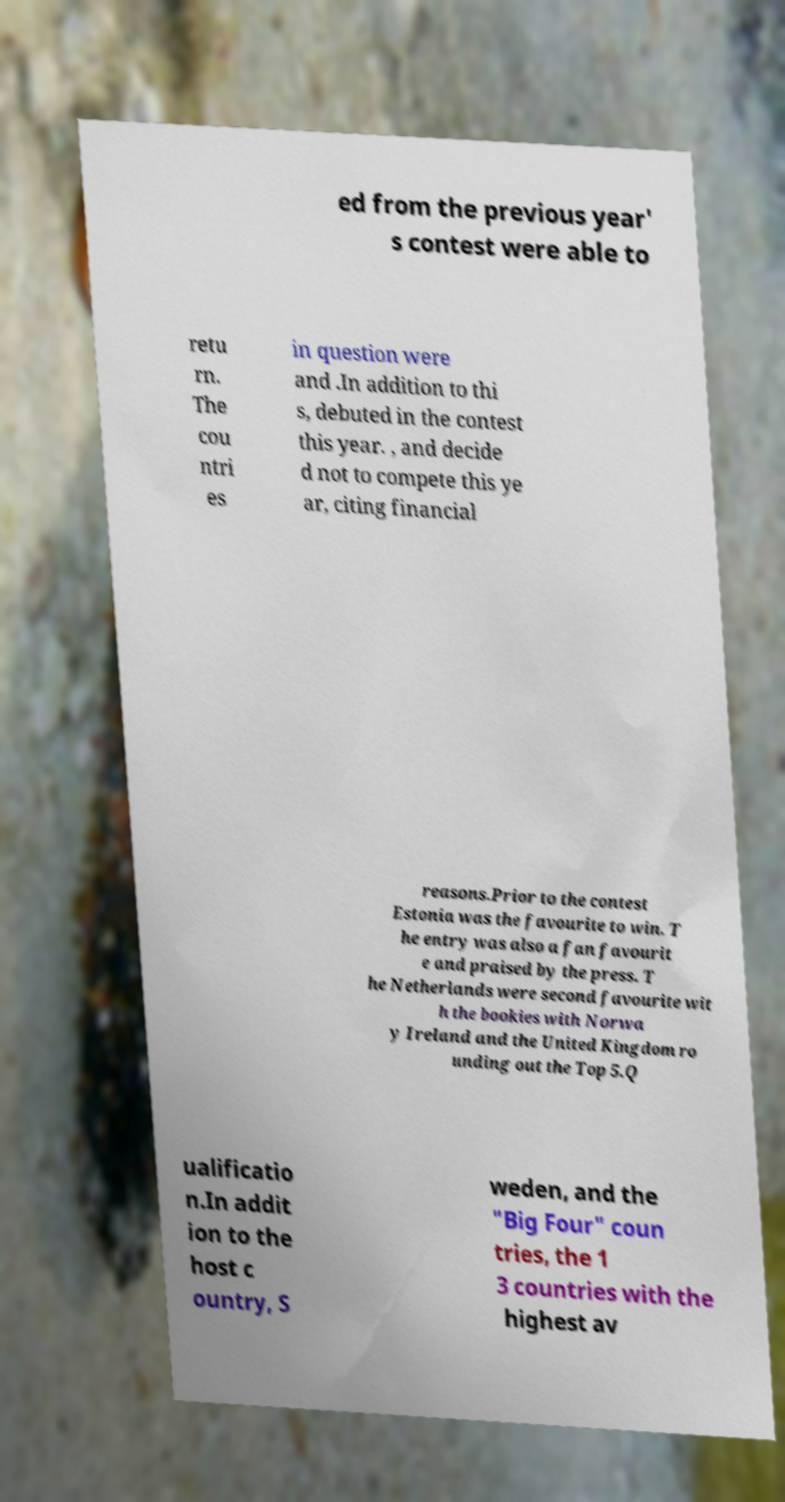I need the written content from this picture converted into text. Can you do that? ed from the previous year' s contest were able to retu rn. The cou ntri es in question were and .In addition to thi s, debuted in the contest this year. , and decide d not to compete this ye ar, citing financial reasons.Prior to the contest Estonia was the favourite to win. T he entry was also a fan favourit e and praised by the press. T he Netherlands were second favourite wit h the bookies with Norwa y Ireland and the United Kingdom ro unding out the Top 5.Q ualificatio n.In addit ion to the host c ountry, S weden, and the "Big Four" coun tries, the 1 3 countries with the highest av 